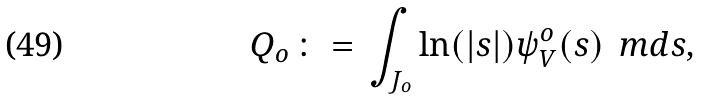<formula> <loc_0><loc_0><loc_500><loc_500>Q _ { o } \, \colon = \, \int _ { J _ { o } } \ln ( | s | ) \psi _ { V } ^ { o } ( s ) \, \ m d s ,</formula> 